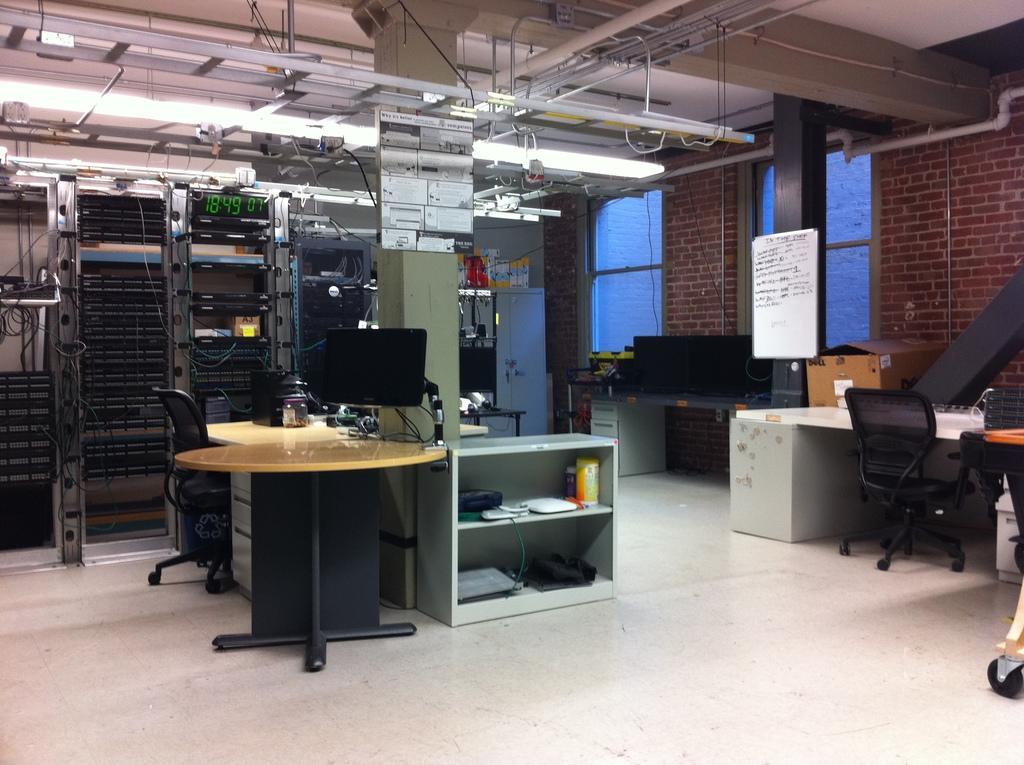Please provide a concise description of this image. This is an inner view of a building. In this image we can see a table containing a laptop and some containers on it, some chairs, a pillar, a cupboard with some objects placed in the shelves, a board with some text on it and a cardboard box. We can also see some electrical devices, a wardrobe, a digital screen and some ceiling lights and pipes to a roof. 